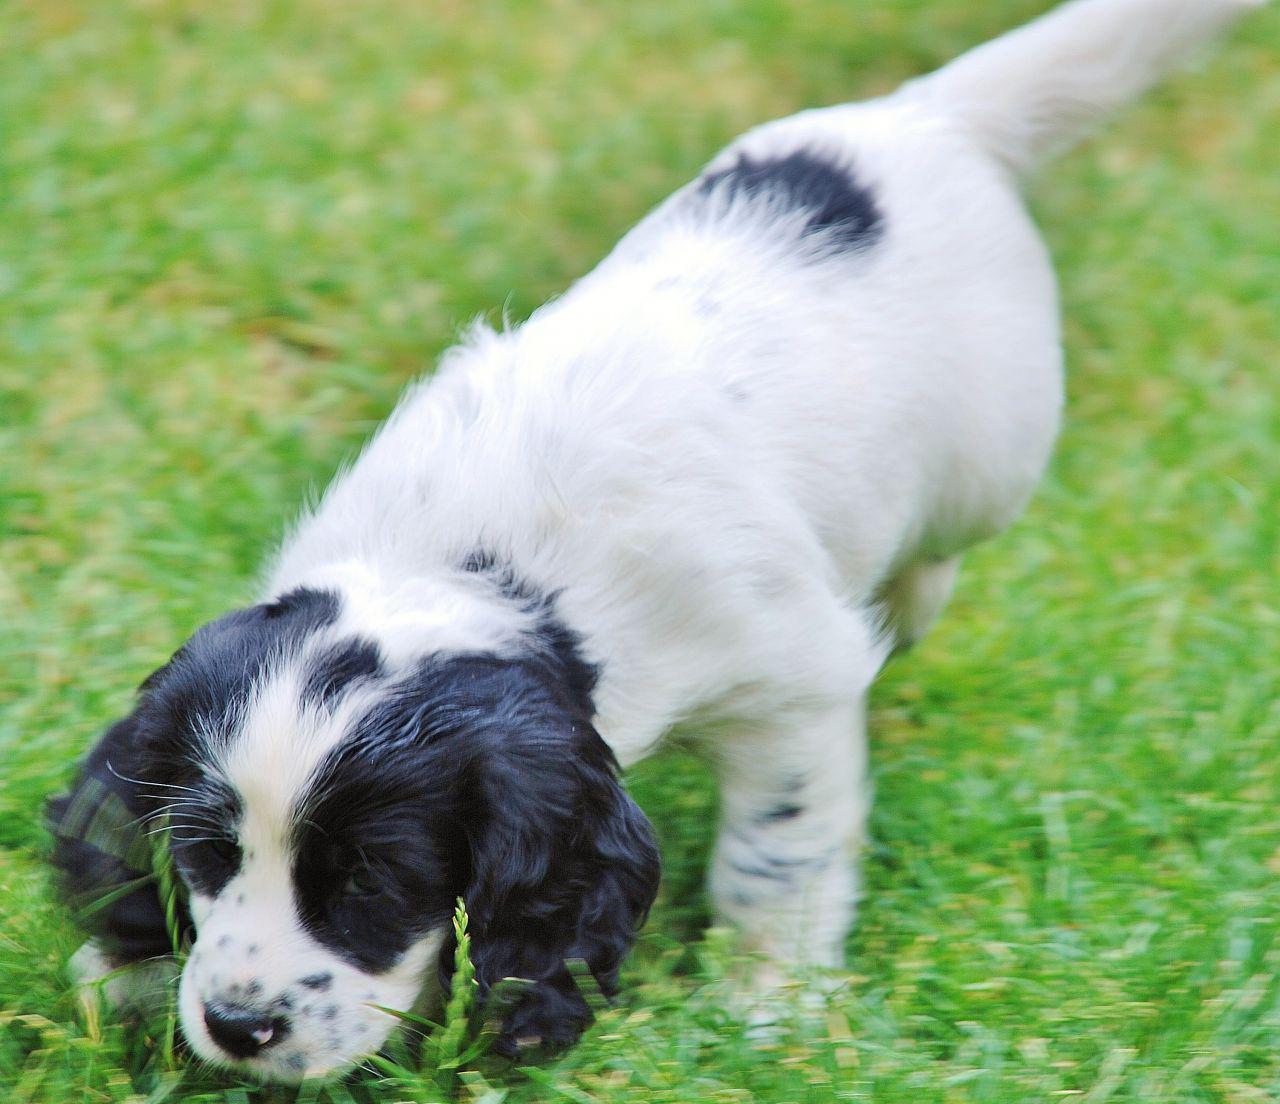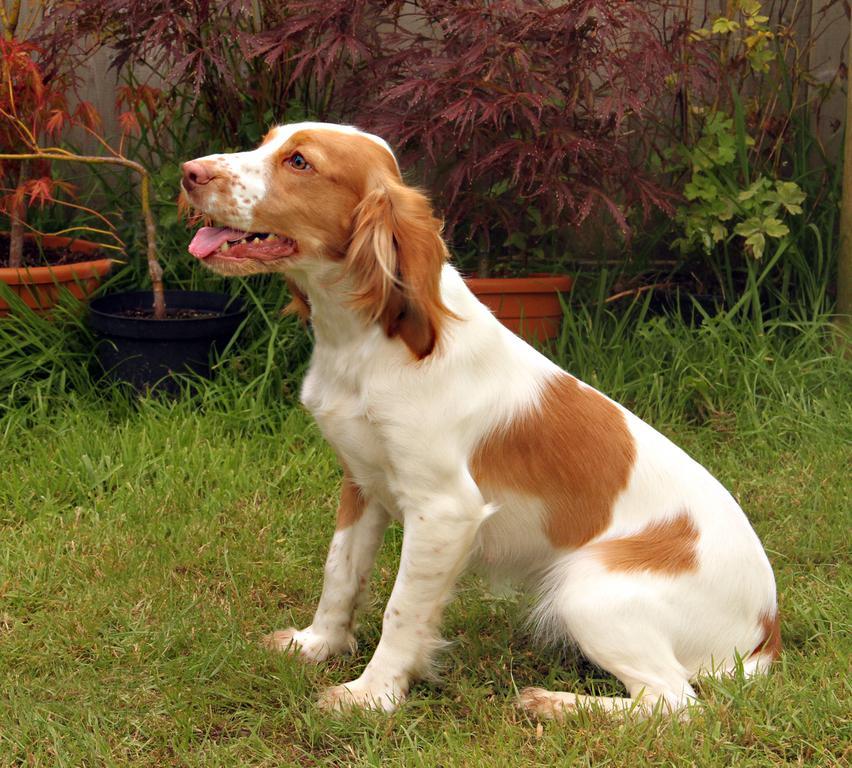The first image is the image on the left, the second image is the image on the right. Given the left and right images, does the statement "One of the dogs is white with black spots." hold true? Answer yes or no. Yes. The first image is the image on the left, the second image is the image on the right. For the images shown, is this caption "One image shows one leftward turned brown-and-white spaniel that is sitting upright outdoors." true? Answer yes or no. Yes. 